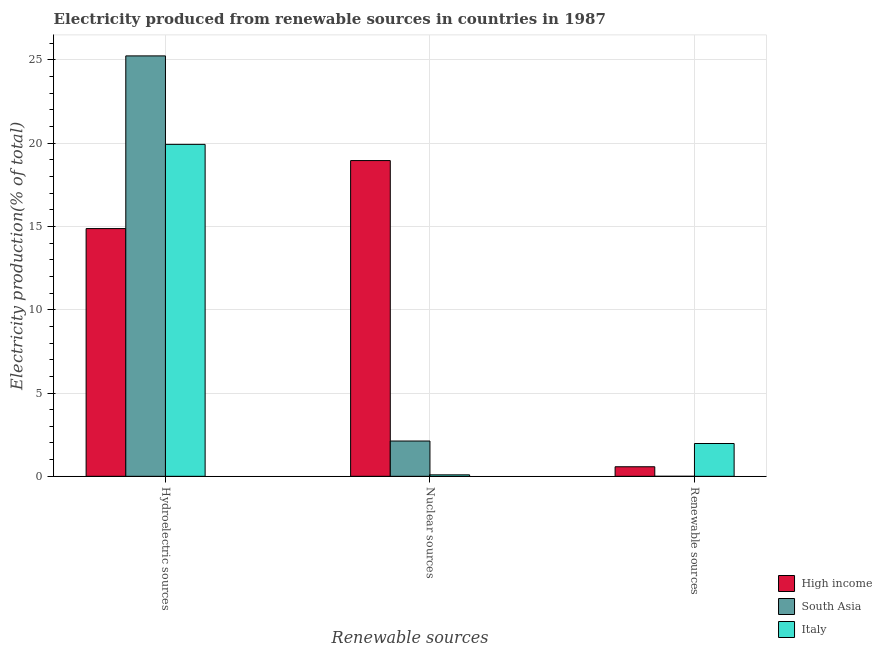Are the number of bars per tick equal to the number of legend labels?
Your response must be concise. Yes. How many bars are there on the 3rd tick from the left?
Offer a terse response. 3. What is the label of the 2nd group of bars from the left?
Your answer should be compact. Nuclear sources. What is the percentage of electricity produced by hydroelectric sources in South Asia?
Keep it short and to the point. 25.23. Across all countries, what is the maximum percentage of electricity produced by hydroelectric sources?
Provide a short and direct response. 25.23. Across all countries, what is the minimum percentage of electricity produced by nuclear sources?
Give a very brief answer. 0.09. What is the total percentage of electricity produced by hydroelectric sources in the graph?
Keep it short and to the point. 60.02. What is the difference between the percentage of electricity produced by hydroelectric sources in Italy and that in High income?
Provide a succinct answer. 5.05. What is the difference between the percentage of electricity produced by nuclear sources in South Asia and the percentage of electricity produced by renewable sources in High income?
Give a very brief answer. 1.54. What is the average percentage of electricity produced by nuclear sources per country?
Make the answer very short. 7.05. What is the difference between the percentage of electricity produced by hydroelectric sources and percentage of electricity produced by nuclear sources in South Asia?
Keep it short and to the point. 23.11. What is the ratio of the percentage of electricity produced by renewable sources in Italy to that in High income?
Make the answer very short. 3.43. What is the difference between the highest and the second highest percentage of electricity produced by hydroelectric sources?
Your answer should be compact. 5.31. What is the difference between the highest and the lowest percentage of electricity produced by hydroelectric sources?
Keep it short and to the point. 10.36. In how many countries, is the percentage of electricity produced by renewable sources greater than the average percentage of electricity produced by renewable sources taken over all countries?
Your response must be concise. 1. Is the sum of the percentage of electricity produced by hydroelectric sources in High income and South Asia greater than the maximum percentage of electricity produced by renewable sources across all countries?
Provide a succinct answer. Yes. What does the 2nd bar from the left in Hydroelectric sources represents?
Ensure brevity in your answer.  South Asia. How many bars are there?
Offer a very short reply. 9. Are all the bars in the graph horizontal?
Provide a short and direct response. No. How many countries are there in the graph?
Offer a very short reply. 3. What is the difference between two consecutive major ticks on the Y-axis?
Provide a short and direct response. 5. What is the title of the graph?
Offer a very short reply. Electricity produced from renewable sources in countries in 1987. Does "Brazil" appear as one of the legend labels in the graph?
Your answer should be very brief. No. What is the label or title of the X-axis?
Offer a terse response. Renewable sources. What is the label or title of the Y-axis?
Your answer should be compact. Electricity production(% of total). What is the Electricity production(% of total) in High income in Hydroelectric sources?
Keep it short and to the point. 14.87. What is the Electricity production(% of total) in South Asia in Hydroelectric sources?
Make the answer very short. 25.23. What is the Electricity production(% of total) in Italy in Hydroelectric sources?
Offer a terse response. 19.92. What is the Electricity production(% of total) in High income in Nuclear sources?
Offer a terse response. 18.95. What is the Electricity production(% of total) in South Asia in Nuclear sources?
Offer a terse response. 2.12. What is the Electricity production(% of total) of Italy in Nuclear sources?
Your answer should be compact. 0.09. What is the Electricity production(% of total) of High income in Renewable sources?
Keep it short and to the point. 0.57. What is the Electricity production(% of total) of South Asia in Renewable sources?
Offer a terse response. 0. What is the Electricity production(% of total) in Italy in Renewable sources?
Offer a very short reply. 1.97. Across all Renewable sources, what is the maximum Electricity production(% of total) of High income?
Offer a terse response. 18.95. Across all Renewable sources, what is the maximum Electricity production(% of total) of South Asia?
Offer a very short reply. 25.23. Across all Renewable sources, what is the maximum Electricity production(% of total) in Italy?
Your response must be concise. 19.92. Across all Renewable sources, what is the minimum Electricity production(% of total) in High income?
Offer a very short reply. 0.57. Across all Renewable sources, what is the minimum Electricity production(% of total) of South Asia?
Give a very brief answer. 0. Across all Renewable sources, what is the minimum Electricity production(% of total) of Italy?
Offer a terse response. 0.09. What is the total Electricity production(% of total) in High income in the graph?
Make the answer very short. 34.39. What is the total Electricity production(% of total) in South Asia in the graph?
Give a very brief answer. 27.35. What is the total Electricity production(% of total) in Italy in the graph?
Give a very brief answer. 21.98. What is the difference between the Electricity production(% of total) of High income in Hydroelectric sources and that in Nuclear sources?
Offer a very short reply. -4.08. What is the difference between the Electricity production(% of total) of South Asia in Hydroelectric sources and that in Nuclear sources?
Give a very brief answer. 23.11. What is the difference between the Electricity production(% of total) of Italy in Hydroelectric sources and that in Nuclear sources?
Ensure brevity in your answer.  19.83. What is the difference between the Electricity production(% of total) in High income in Hydroelectric sources and that in Renewable sources?
Ensure brevity in your answer.  14.29. What is the difference between the Electricity production(% of total) in South Asia in Hydroelectric sources and that in Renewable sources?
Provide a short and direct response. 25.23. What is the difference between the Electricity production(% of total) in Italy in Hydroelectric sources and that in Renewable sources?
Your answer should be compact. 17.95. What is the difference between the Electricity production(% of total) of High income in Nuclear sources and that in Renewable sources?
Your answer should be compact. 18.38. What is the difference between the Electricity production(% of total) in South Asia in Nuclear sources and that in Renewable sources?
Your answer should be very brief. 2.12. What is the difference between the Electricity production(% of total) of Italy in Nuclear sources and that in Renewable sources?
Make the answer very short. -1.88. What is the difference between the Electricity production(% of total) of High income in Hydroelectric sources and the Electricity production(% of total) of South Asia in Nuclear sources?
Offer a terse response. 12.75. What is the difference between the Electricity production(% of total) in High income in Hydroelectric sources and the Electricity production(% of total) in Italy in Nuclear sources?
Provide a succinct answer. 14.78. What is the difference between the Electricity production(% of total) of South Asia in Hydroelectric sources and the Electricity production(% of total) of Italy in Nuclear sources?
Give a very brief answer. 25.14. What is the difference between the Electricity production(% of total) in High income in Hydroelectric sources and the Electricity production(% of total) in South Asia in Renewable sources?
Provide a short and direct response. 14.87. What is the difference between the Electricity production(% of total) of High income in Hydroelectric sources and the Electricity production(% of total) of Italy in Renewable sources?
Make the answer very short. 12.9. What is the difference between the Electricity production(% of total) of South Asia in Hydroelectric sources and the Electricity production(% of total) of Italy in Renewable sources?
Give a very brief answer. 23.26. What is the difference between the Electricity production(% of total) of High income in Nuclear sources and the Electricity production(% of total) of South Asia in Renewable sources?
Your answer should be compact. 18.95. What is the difference between the Electricity production(% of total) in High income in Nuclear sources and the Electricity production(% of total) in Italy in Renewable sources?
Ensure brevity in your answer.  16.98. What is the difference between the Electricity production(% of total) in South Asia in Nuclear sources and the Electricity production(% of total) in Italy in Renewable sources?
Offer a terse response. 0.15. What is the average Electricity production(% of total) of High income per Renewable sources?
Provide a succinct answer. 11.46. What is the average Electricity production(% of total) of South Asia per Renewable sources?
Offer a terse response. 9.12. What is the average Electricity production(% of total) in Italy per Renewable sources?
Make the answer very short. 7.33. What is the difference between the Electricity production(% of total) of High income and Electricity production(% of total) of South Asia in Hydroelectric sources?
Make the answer very short. -10.36. What is the difference between the Electricity production(% of total) of High income and Electricity production(% of total) of Italy in Hydroelectric sources?
Offer a terse response. -5.05. What is the difference between the Electricity production(% of total) of South Asia and Electricity production(% of total) of Italy in Hydroelectric sources?
Offer a very short reply. 5.31. What is the difference between the Electricity production(% of total) of High income and Electricity production(% of total) of South Asia in Nuclear sources?
Provide a succinct answer. 16.83. What is the difference between the Electricity production(% of total) in High income and Electricity production(% of total) in Italy in Nuclear sources?
Offer a terse response. 18.86. What is the difference between the Electricity production(% of total) in South Asia and Electricity production(% of total) in Italy in Nuclear sources?
Give a very brief answer. 2.03. What is the difference between the Electricity production(% of total) in High income and Electricity production(% of total) in South Asia in Renewable sources?
Your response must be concise. 0.57. What is the difference between the Electricity production(% of total) of High income and Electricity production(% of total) of Italy in Renewable sources?
Offer a terse response. -1.4. What is the difference between the Electricity production(% of total) in South Asia and Electricity production(% of total) in Italy in Renewable sources?
Provide a short and direct response. -1.97. What is the ratio of the Electricity production(% of total) of High income in Hydroelectric sources to that in Nuclear sources?
Keep it short and to the point. 0.78. What is the ratio of the Electricity production(% of total) of South Asia in Hydroelectric sources to that in Nuclear sources?
Offer a terse response. 11.91. What is the ratio of the Electricity production(% of total) of Italy in Hydroelectric sources to that in Nuclear sources?
Keep it short and to the point. 227.04. What is the ratio of the Electricity production(% of total) in High income in Hydroelectric sources to that in Renewable sources?
Make the answer very short. 25.89. What is the ratio of the Electricity production(% of total) in South Asia in Hydroelectric sources to that in Renewable sources?
Keep it short and to the point. 2.20e+04. What is the ratio of the Electricity production(% of total) of Italy in Hydroelectric sources to that in Renewable sources?
Make the answer very short. 10.12. What is the ratio of the Electricity production(% of total) of High income in Nuclear sources to that in Renewable sources?
Provide a succinct answer. 33. What is the ratio of the Electricity production(% of total) of South Asia in Nuclear sources to that in Renewable sources?
Make the answer very short. 1845.67. What is the ratio of the Electricity production(% of total) in Italy in Nuclear sources to that in Renewable sources?
Give a very brief answer. 0.04. What is the difference between the highest and the second highest Electricity production(% of total) in High income?
Your answer should be compact. 4.08. What is the difference between the highest and the second highest Electricity production(% of total) of South Asia?
Your answer should be compact. 23.11. What is the difference between the highest and the second highest Electricity production(% of total) of Italy?
Keep it short and to the point. 17.95. What is the difference between the highest and the lowest Electricity production(% of total) of High income?
Ensure brevity in your answer.  18.38. What is the difference between the highest and the lowest Electricity production(% of total) in South Asia?
Your answer should be compact. 25.23. What is the difference between the highest and the lowest Electricity production(% of total) of Italy?
Provide a succinct answer. 19.83. 